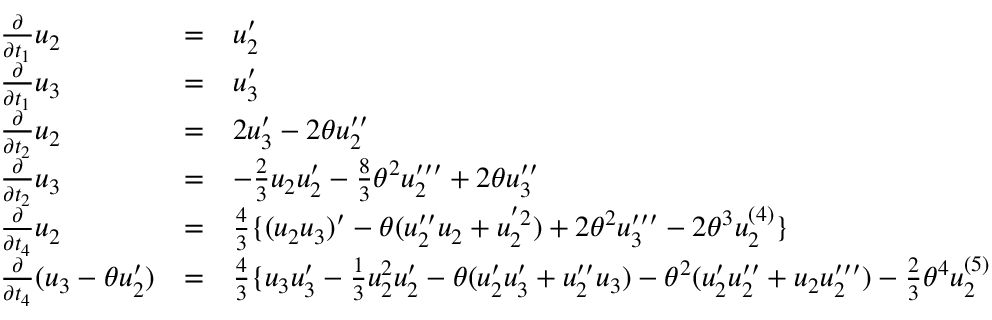<formula> <loc_0><loc_0><loc_500><loc_500>\begin{array} { l c l } { { \frac { \partial } { \partial t _ { 1 } } { u _ { 2 } } } } & { = } & { { { u _ { 2 } ^ { \prime } } } } \\ { { \frac { \partial } { \partial t _ { 1 } } { u _ { 3 } } } } & { = } & { { { u _ { 3 } ^ { \prime } } } } \\ { { \frac { \partial } { \partial t _ { 2 } } { u _ { 2 } } } } & { = } & { { 2 { u _ { 3 } ^ { \prime } } - 2 \theta u _ { 2 } ^ { \prime \prime } } } \\ { { \frac { \partial } { \partial t _ { 2 } } { u _ { 3 } } } } & { = } & { { - \frac { 2 } { 3 } u _ { 2 } u _ { 2 } ^ { \prime } - \frac { 8 } { 3 } \theta ^ { 2 } u _ { 2 } ^ { \prime \prime \prime } + 2 \theta u _ { 3 } ^ { \prime \prime } } } \\ { { \frac { \partial } { \partial t _ { 4 } } { u _ { 2 } } } } & { = } & { { \frac { 4 } { 3 } \{ ( u _ { 2 } u _ { 3 } ) ^ { \prime } - \theta ( u _ { 2 } ^ { \prime \prime } u _ { 2 } + u _ { 2 } ^ { ^ { \prime } 2 } ) + 2 { \theta } ^ { 2 } u _ { 3 } ^ { \prime \prime \prime } - 2 { \theta } ^ { 3 } u _ { 2 } ^ { ( 4 ) } \} } } \\ { { \frac { \partial } { \partial t _ { 4 } } { ( u _ { 3 } - \theta u _ { 2 } ^ { \prime } ) } } } & { = } & { { \frac { 4 } { 3 } \{ u _ { 3 } u _ { 3 } ^ { \prime } - \frac { 1 } { 3 } u _ { 2 } ^ { 2 } u _ { 2 } ^ { \prime } - \theta ( u _ { 2 } ^ { \prime } u _ { 3 } ^ { \prime } + u _ { 2 } ^ { \prime \prime } u _ { 3 } ) - \theta ^ { 2 } ( u _ { 2 } ^ { \prime } u _ { 2 } ^ { \prime \prime } + u _ { 2 } u _ { 2 } ^ { \prime \prime \prime } ) - \frac { 2 } { 3 } \theta ^ { 4 } u _ { 2 } ^ { ( 5 ) } . } } \end{array}</formula> 